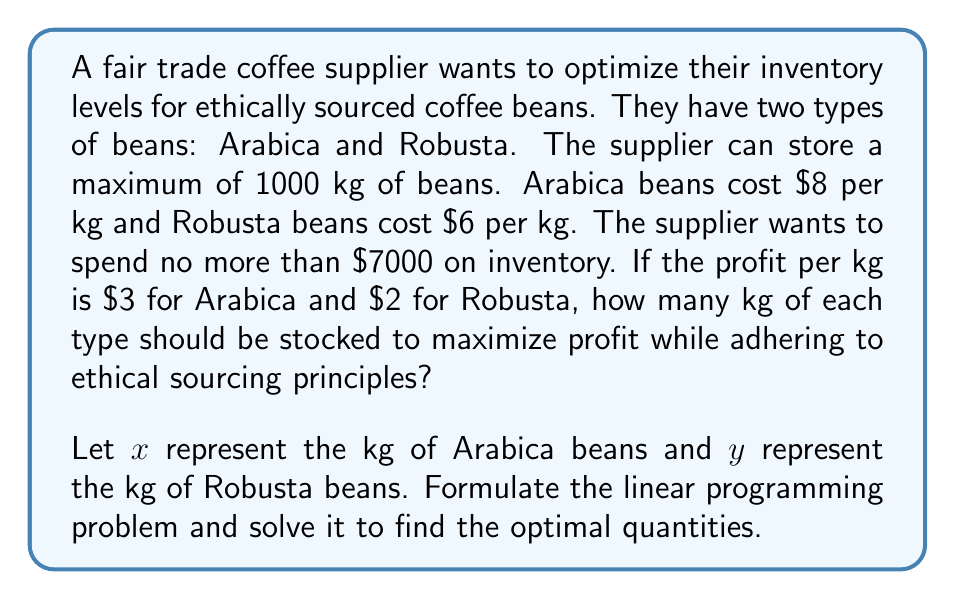Help me with this question. To solve this problem, we need to set up a linear programming model and solve it:

1. Define variables:
   $x$ = kg of Arabica beans
   $y$ = kg of Robusta beans

2. Objective function (maximize profit):
   Maximize $Z = 3x + 2y$

3. Constraints:
   a. Total storage: $x + y \leq 1000$
   b. Budget: $8x + 6y \leq 7000$
   c. Non-negativity: $x \geq 0, y \geq 0$

4. Solve using the corner point method:

   Find corner points:
   (0, 0): Trivial point
   (875, 0): From budget constraint when y = 0
   (0, 1000): Not feasible due to budget constraint
   (0, 1166.67): From budget constraint when x = 0, but not feasible due to storage constraint
   (500, 500): Intersection of storage and budget constraints

   Calculate Z for each feasible point:
   (0, 0): Z = 0
   (875, 0): Z = 3(875) + 2(0) = 2625
   (500, 500): Z = 3(500) + 2(500) = 2500

5. The maximum profit occurs at (875, 0), meaning 875 kg of Arabica beans and 0 kg of Robusta beans.
Answer: 875 kg Arabica, 0 kg Robusta 